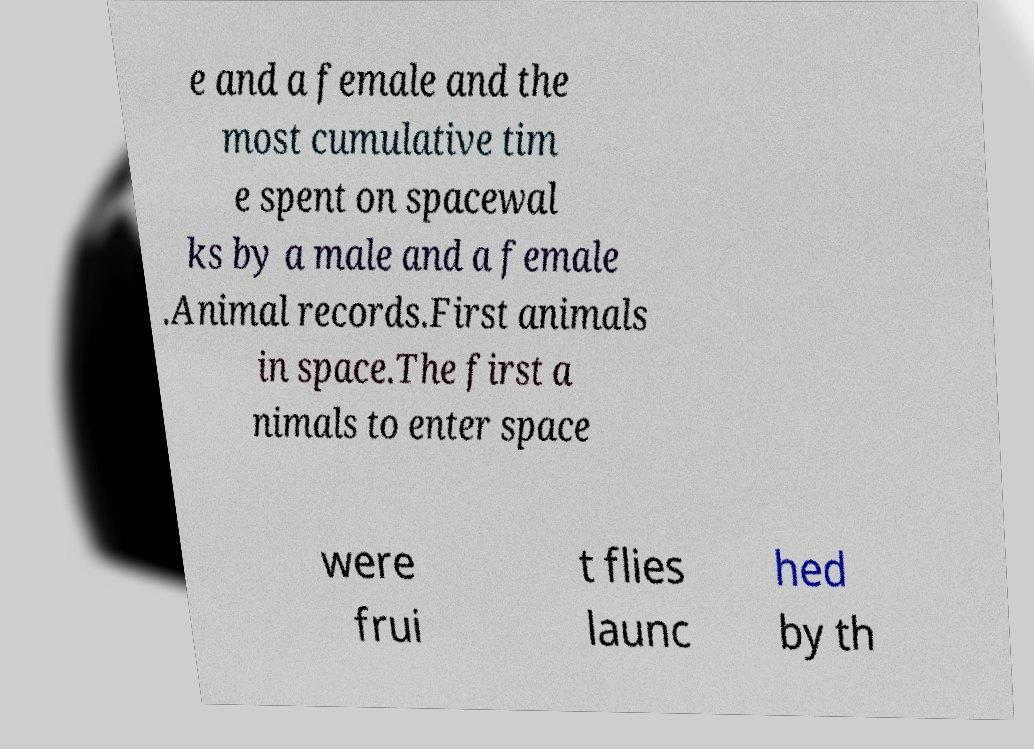Can you read and provide the text displayed in the image?This photo seems to have some interesting text. Can you extract and type it out for me? e and a female and the most cumulative tim e spent on spacewal ks by a male and a female .Animal records.First animals in space.The first a nimals to enter space were frui t flies launc hed by th 